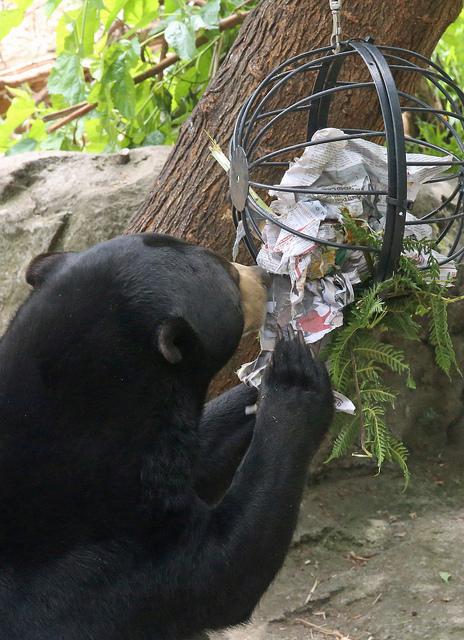What is this bear eating?
Give a very brief answer. Trash. What color is the bear?
Concise answer only. Black. How many bears are pictured?
Be succinct. 1. What is the bear reaching for?
Be succinct. Paper. 